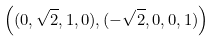<formula> <loc_0><loc_0><loc_500><loc_500>\left ( ( 0 , \sqrt { 2 } , 1 , 0 ) , ( - \sqrt { 2 } , 0 , 0 , 1 ) \right )</formula> 